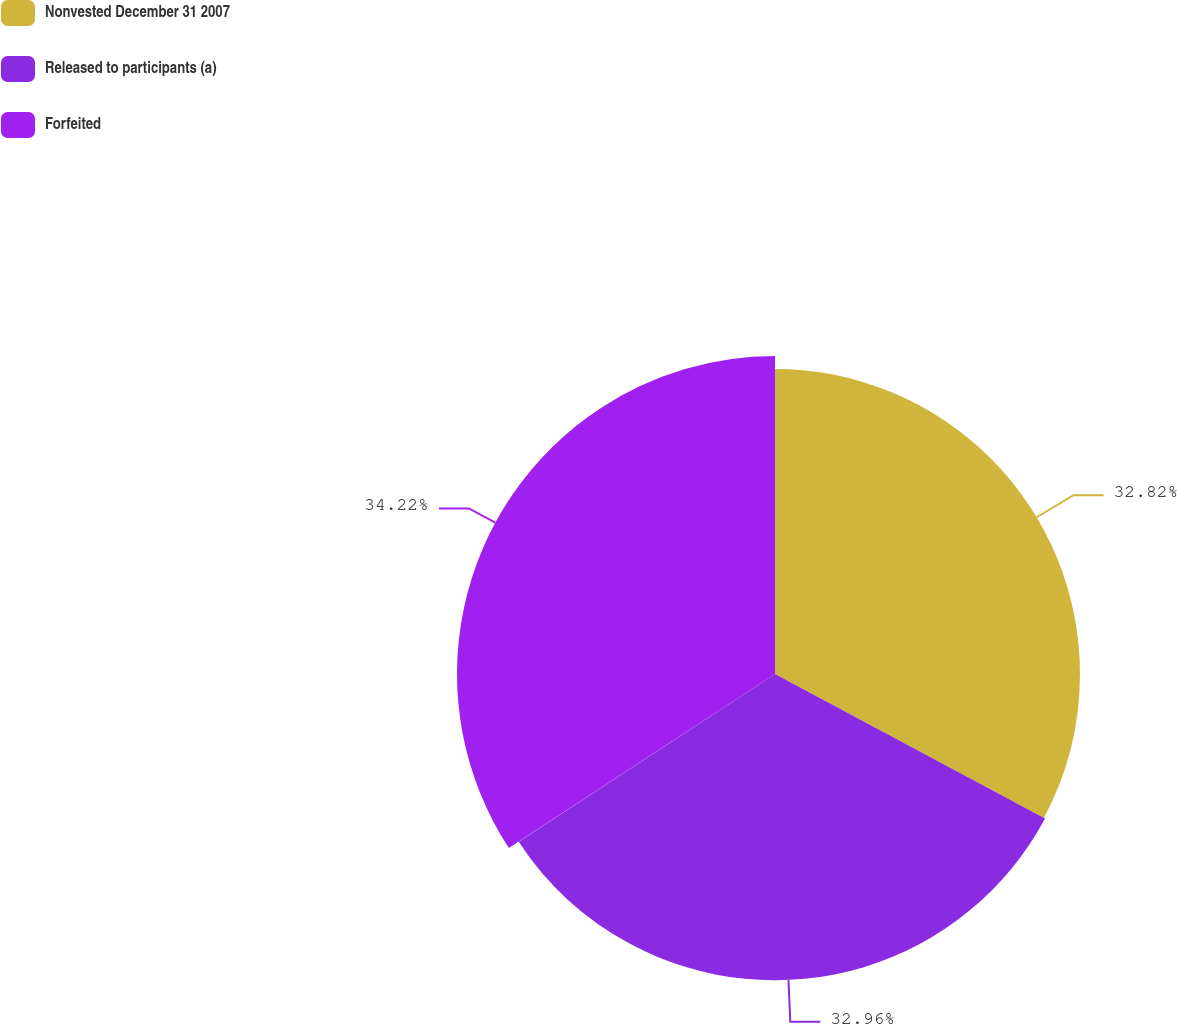<chart> <loc_0><loc_0><loc_500><loc_500><pie_chart><fcel>Nonvested December 31 2007<fcel>Released to participants (a)<fcel>Forfeited<nl><fcel>32.82%<fcel>32.96%<fcel>34.22%<nl></chart> 